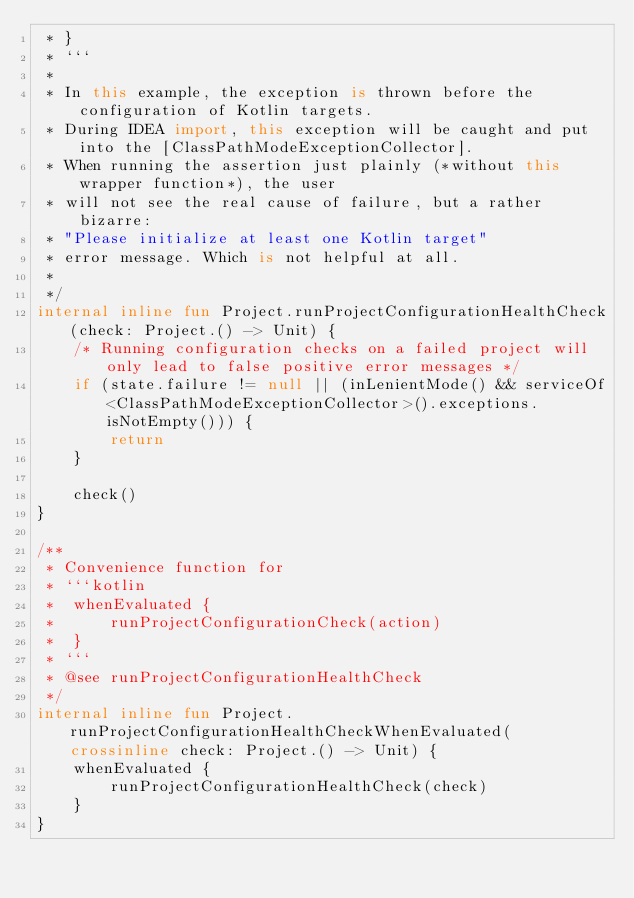<code> <loc_0><loc_0><loc_500><loc_500><_Kotlin_> * }
 * ```
 *
 * In this example, the exception is thrown before the configuration of Kotlin targets.
 * During IDEA import, this exception will be caught and put into the [ClassPathModeExceptionCollector].
 * When running the assertion just plainly (*without this wrapper function*), the user
 * will not see the real cause of failure, but a rather bizarre:
 * "Please initialize at least one Kotlin target"
 * error message. Which is not helpful at all.
 *
 */
internal inline fun Project.runProjectConfigurationHealthCheck(check: Project.() -> Unit) {
    /* Running configuration checks on a failed project will only lead to false positive error messages */
    if (state.failure != null || (inLenientMode() && serviceOf<ClassPathModeExceptionCollector>().exceptions.isNotEmpty())) {
        return
    }

    check()
}

/**
 * Convenience function for
 * ```kotlin
 *  whenEvaluated {
 *      runProjectConfigurationCheck(action)
 *  }
 * ```
 * @see runProjectConfigurationHealthCheck
 */
internal inline fun Project.runProjectConfigurationHealthCheckWhenEvaluated(crossinline check: Project.() -> Unit) {
    whenEvaluated {
        runProjectConfigurationHealthCheck(check)
    }
}
</code> 